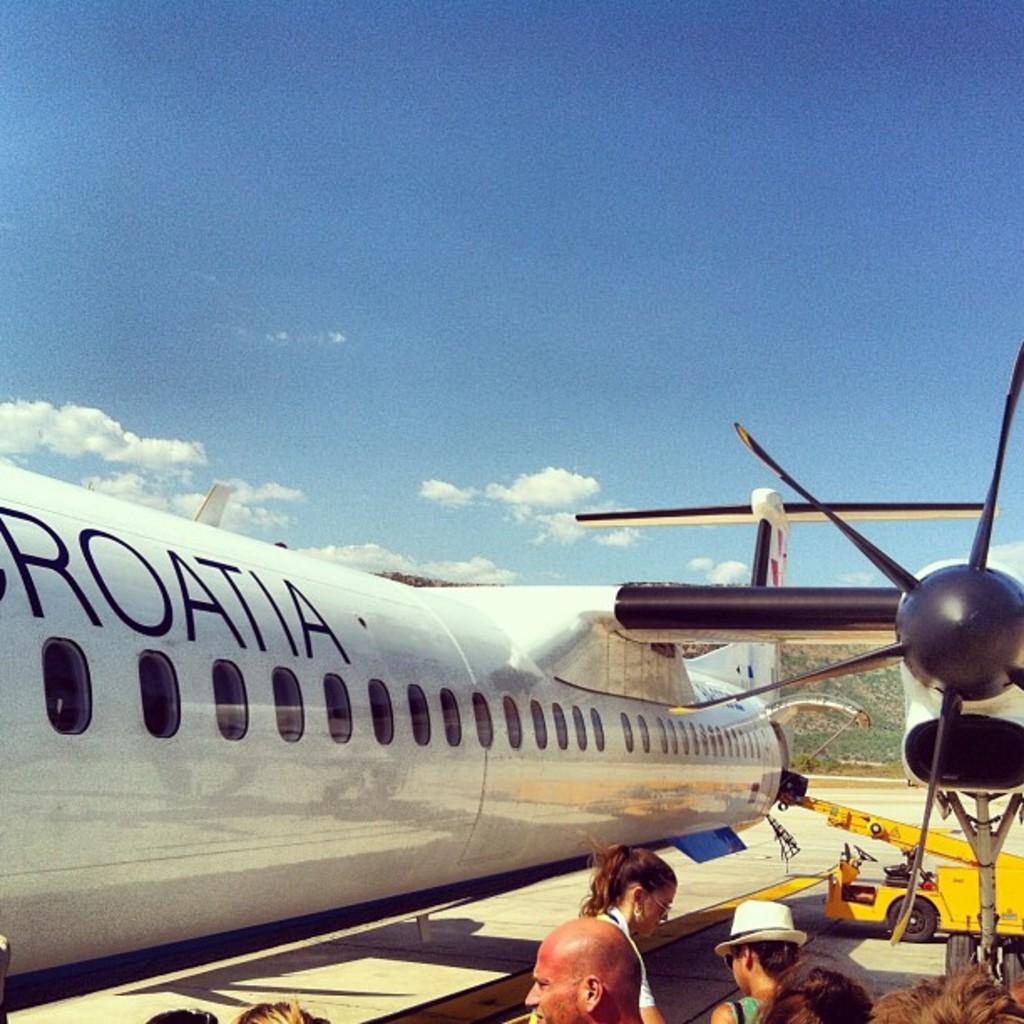What does it say on the plane?
Offer a terse response. Croatia. 